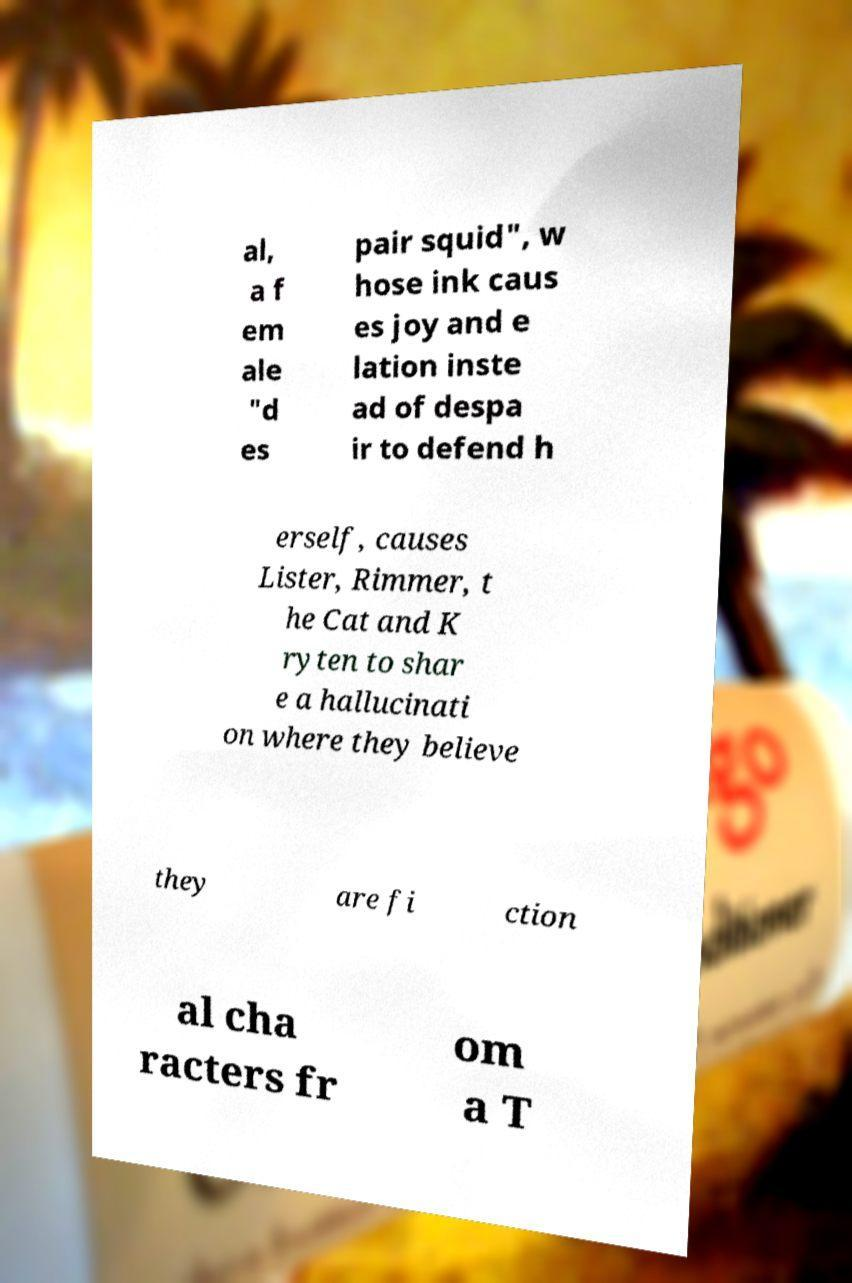Please identify and transcribe the text found in this image. al, a f em ale "d es pair squid", w hose ink caus es joy and e lation inste ad of despa ir to defend h erself, causes Lister, Rimmer, t he Cat and K ryten to shar e a hallucinati on where they believe they are fi ction al cha racters fr om a T 